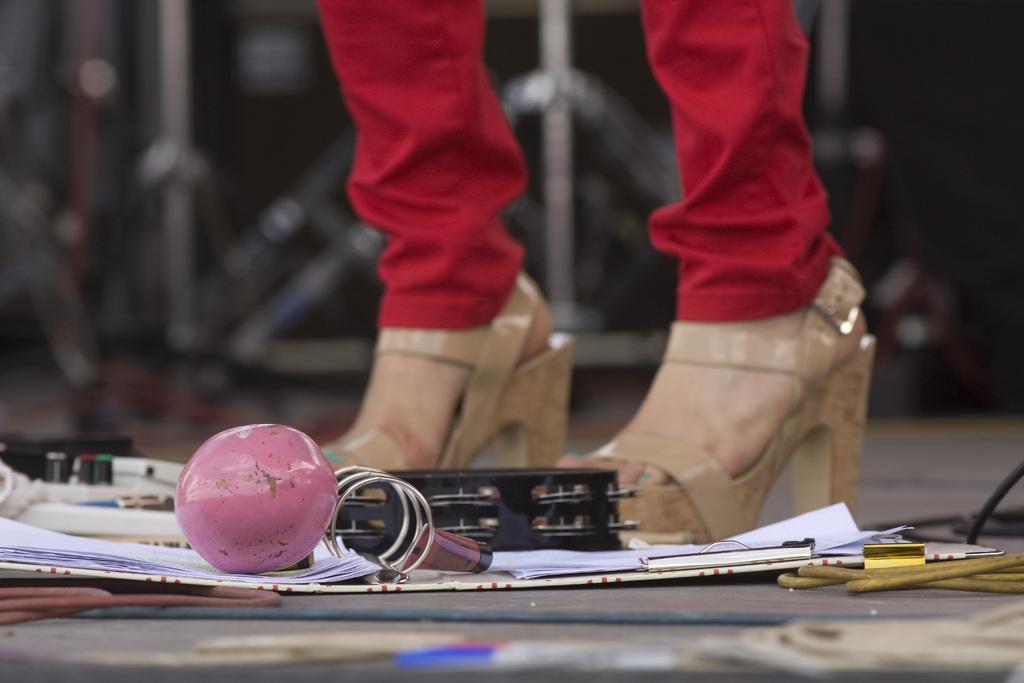Please provide a concise description of this image. In this image I can see the ground, a file, few papers in the file and a pink colored object on the file. I can see a person wearing red colored pant and brown colored footwear is standing. I can see the blurry background. 